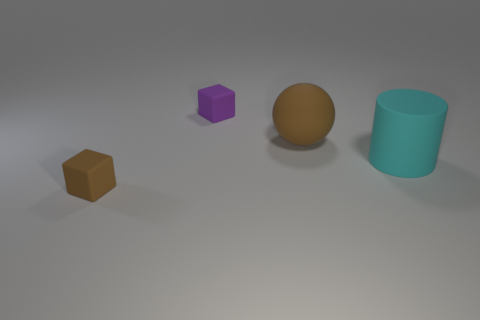There is a matte thing on the left side of the cube behind the brown rubber cube; how many tiny brown things are on the right side of it?
Provide a succinct answer. 0. There is a cyan object; does it have the same size as the brown rubber object that is behind the brown cube?
Keep it short and to the point. Yes. How big is the brown thing that is behind the matte thing that is in front of the cyan rubber object?
Your answer should be compact. Large. How many large cyan cylinders have the same material as the big sphere?
Your response must be concise. 1. Are any large yellow rubber cubes visible?
Offer a terse response. No. What is the size of the brown object that is behind the cyan rubber cylinder?
Provide a short and direct response. Large. What number of small matte things have the same color as the large ball?
Offer a very short reply. 1. What number of spheres are large things or large brown things?
Your answer should be compact. 1. What is the shape of the matte thing that is on the left side of the cyan rubber cylinder and to the right of the tiny purple matte block?
Your answer should be very brief. Sphere. Is there a rubber sphere of the same size as the cyan matte object?
Give a very brief answer. Yes. 